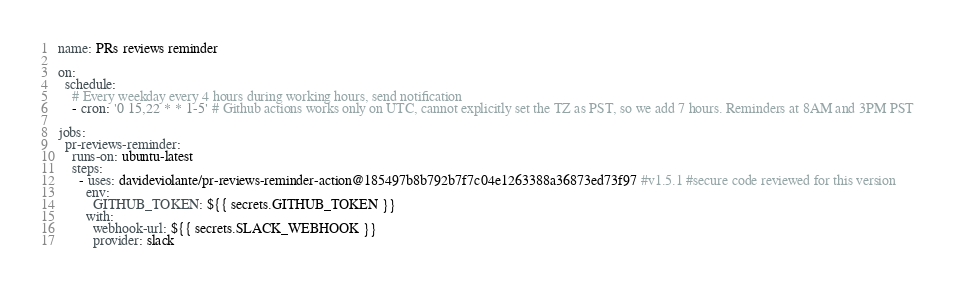<code> <loc_0><loc_0><loc_500><loc_500><_YAML_>name: PRs reviews reminder

on:
  schedule:
    # Every weekday every 4 hours during working hours, send notification
    - cron: '0 15,22 * * 1-5' # Github actions works only on UTC, cannot explicitly set the TZ as PST, so we add 7 hours. Reminders at 8AM and 3PM PST

jobs:
  pr-reviews-reminder:
    runs-on: ubuntu-latest
    steps:
      - uses: davideviolante/pr-reviews-reminder-action@185497b8b792b7f7c04e1263388a36873ed73f97 #v1.5.1 #secure code reviewed for this version
        env:
          GITHUB_TOKEN: ${{ secrets.GITHUB_TOKEN }}
        with:
          webhook-url: ${{ secrets.SLACK_WEBHOOK }}
          provider: slack
</code> 